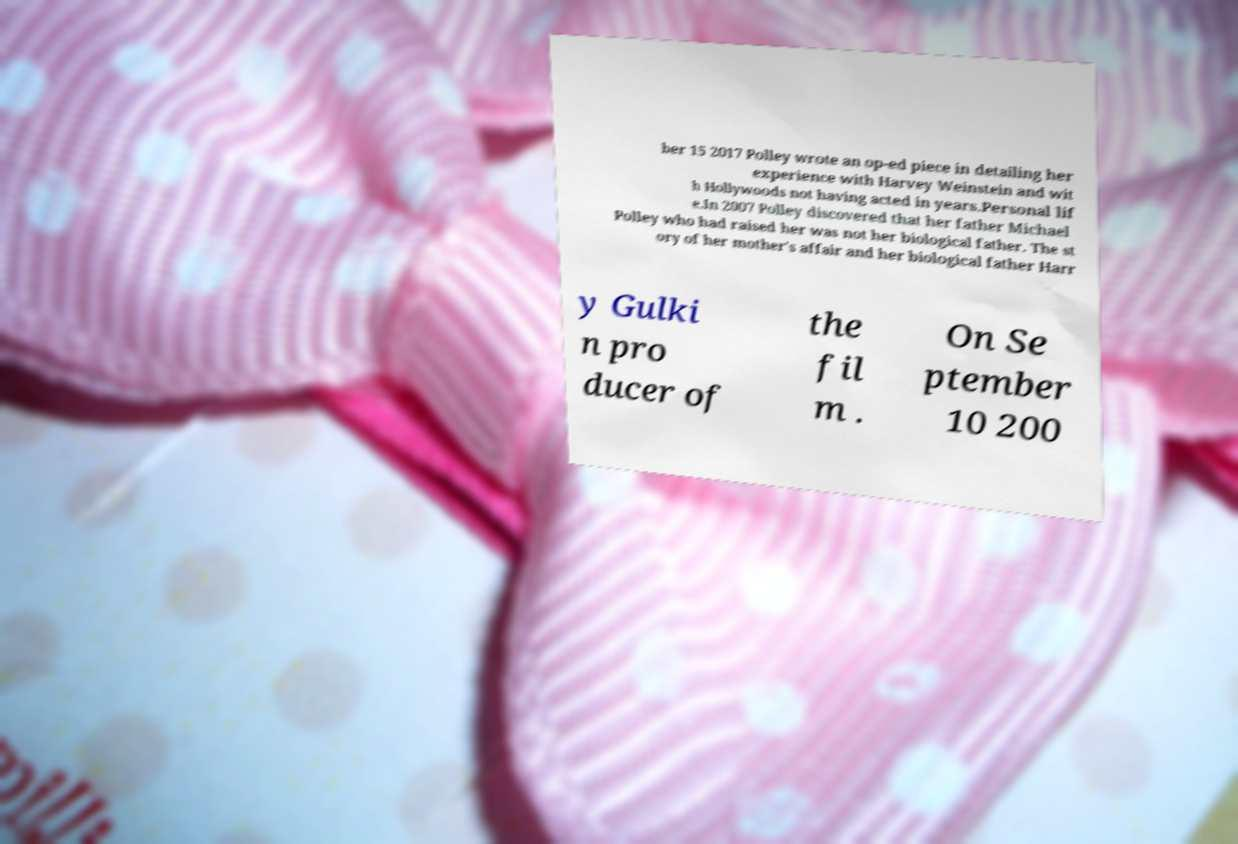Could you extract and type out the text from this image? ber 15 2017 Polley wrote an op-ed piece in detailing her experience with Harvey Weinstein and wit h Hollywoods not having acted in years.Personal lif e.In 2007 Polley discovered that her father Michael Polley who had raised her was not her biological father. The st ory of her mother's affair and her biological father Harr y Gulki n pro ducer of the fil m . On Se ptember 10 200 